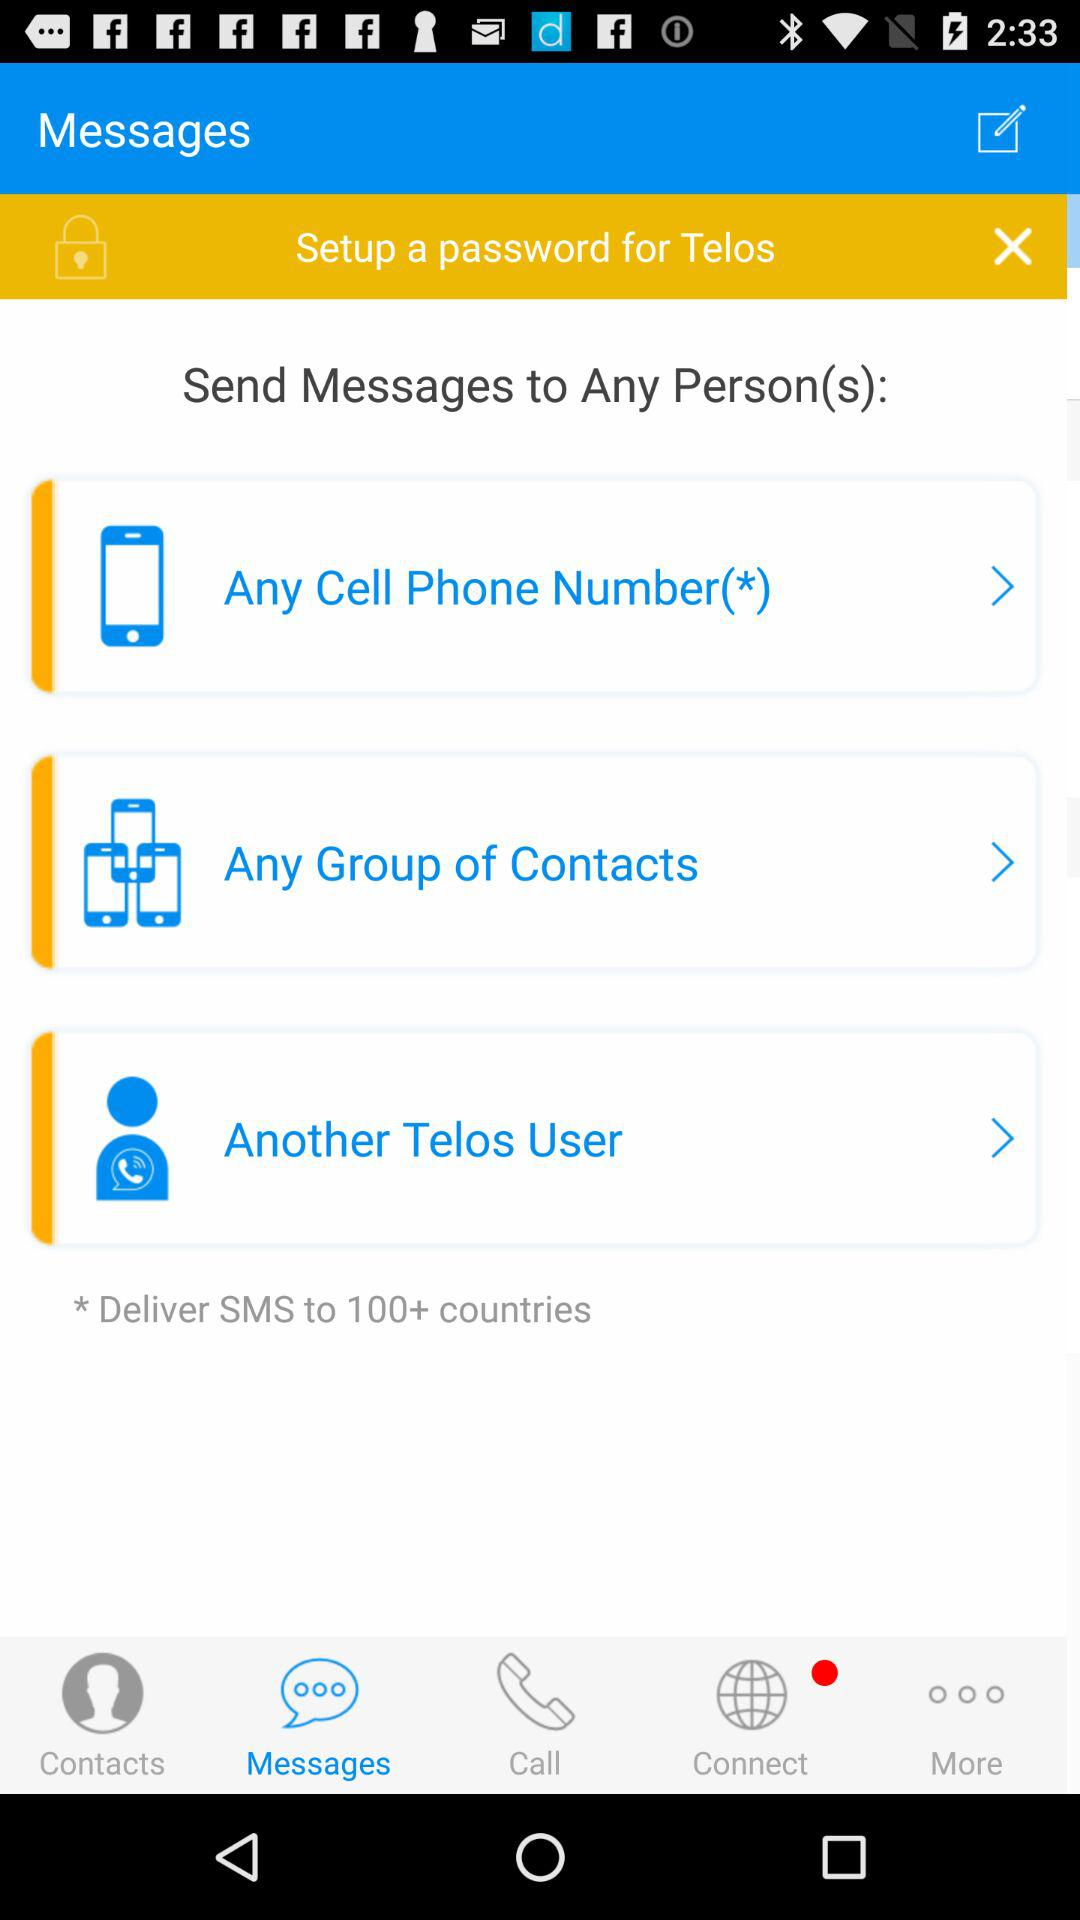Which tab is selected? The selected tab is "Messages". 